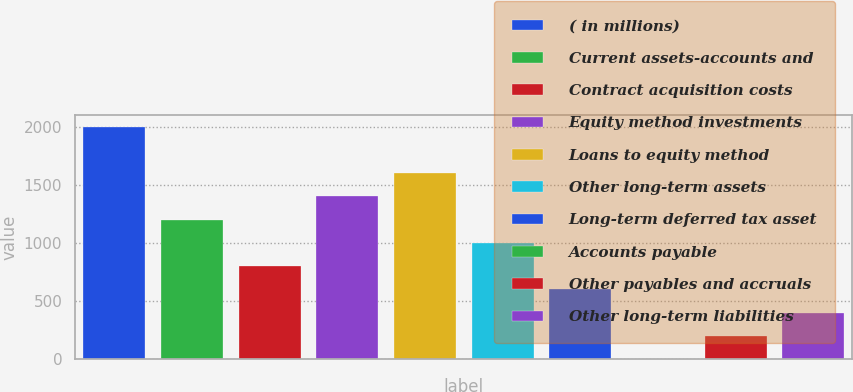Convert chart. <chart><loc_0><loc_0><loc_500><loc_500><bar_chart><fcel>( in millions)<fcel>Current assets-accounts and<fcel>Contract acquisition costs<fcel>Equity method investments<fcel>Loans to equity method<fcel>Other long-term assets<fcel>Long-term deferred tax asset<fcel>Accounts payable<fcel>Other payables and accruals<fcel>Other long-term liabilities<nl><fcel>2004<fcel>1203.6<fcel>803.4<fcel>1403.7<fcel>1603.8<fcel>1003.5<fcel>603.3<fcel>3<fcel>203.1<fcel>403.2<nl></chart> 